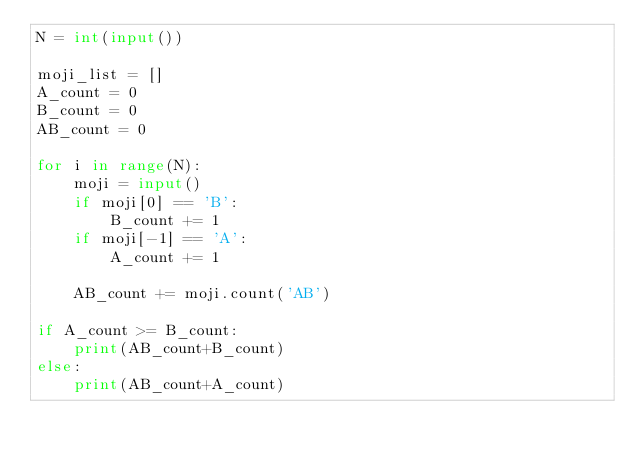Convert code to text. <code><loc_0><loc_0><loc_500><loc_500><_Python_>N = int(input())

moji_list = []
A_count = 0
B_count = 0
AB_count = 0

for i in range(N):
    moji = input()
    if moji[0] == 'B':
        B_count += 1
    if moji[-1] == 'A':
        A_count += 1
    
    AB_count += moji.count('AB')

if A_count >= B_count:
    print(AB_count+B_count)
else:
    print(AB_count+A_count)

</code> 